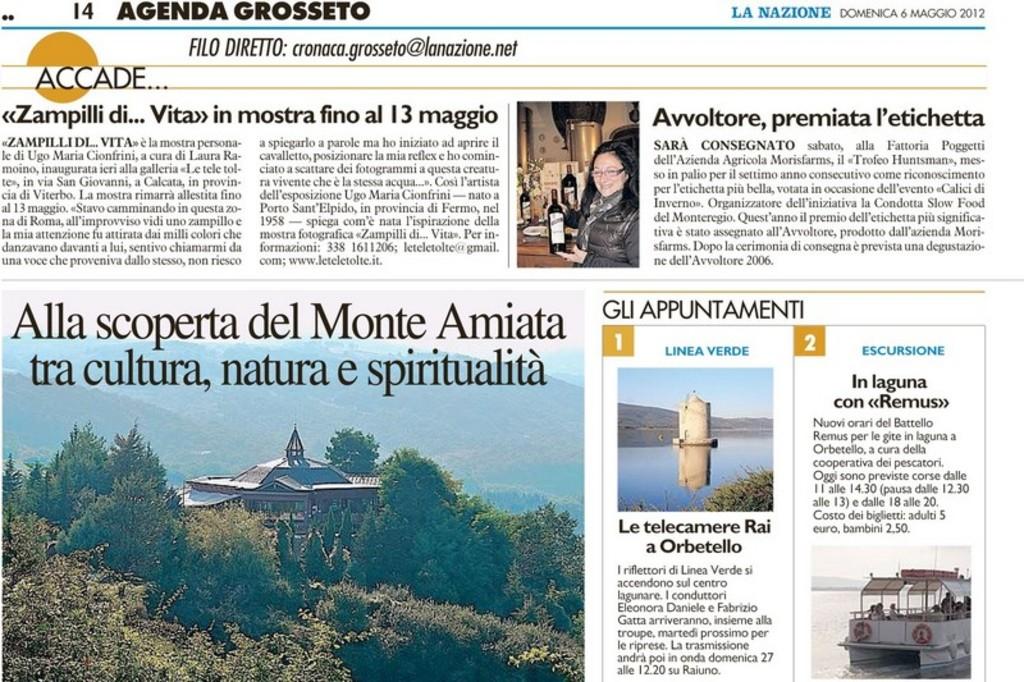What is the name of this magazine?
Provide a short and direct response. Agenda grosseto. What year is this from?
Make the answer very short. 2012. 